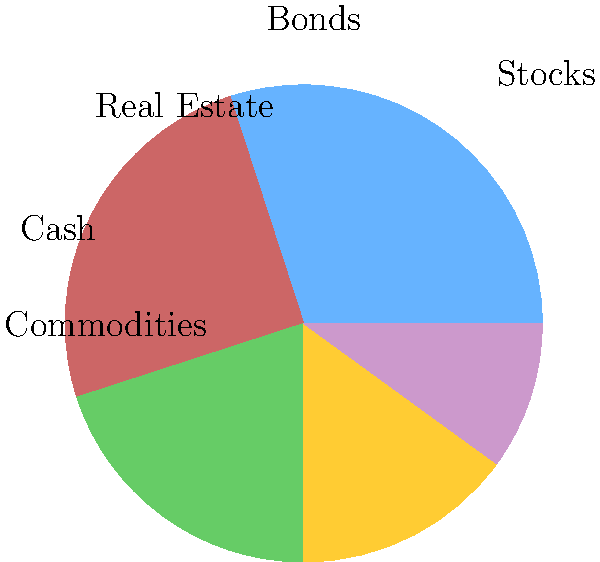Based on the pie chart representing a diversified investment portfolio, which asset class has the highest allocation, and how does this align with the risk profile typically associated with a career in corporate finance? To answer this question, let's follow these steps:

1. Analyze the pie chart:
   - Stocks: 30%
   - Bonds: 25%
   - Real Estate: 20%
   - Cash: 15%
   - Commodities: 10%

2. Identify the highest allocation:
   The asset class with the highest allocation is Stocks at 30%.

3. Consider the risk profile associated with a career in corporate finance:
   - Corporate finance professionals often deal with complex financial structures and investment strategies.
   - They need to understand both conservative and aggressive investment approaches.
   - A balanced portfolio with a slight tilt towards growth is often preferred.

4. Evaluate the alignment:
   - Stocks (30%) being the highest allocation aligns well with the risk profile of a corporate finance career.
   - It indicates a growth-oriented approach while still maintaining diversification.
   - The significant allocations to bonds (25%) and real estate (20%) provide stability and income.
   - The smaller allocations to cash (15%) and commodities (10%) offer liquidity and inflation protection.

5. Conclusion:
   The portfolio's highest allocation to stocks (30%) aligns well with the risk profile typically associated with a career in corporate finance. It demonstrates a balance between seeking growth and managing risk through diversification.
Answer: Stocks (30%); aligns well due to growth focus balanced with diversification. 